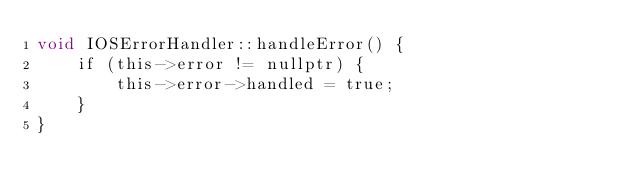Convert code to text. <code><loc_0><loc_0><loc_500><loc_500><_ObjectiveC_>void IOSErrorHandler::handleError() {
    if (this->error != nullptr) {
        this->error->handled = true;
    }
}
</code> 